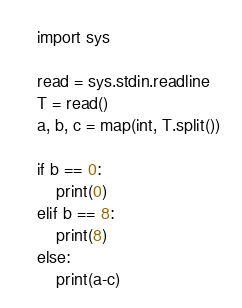<code> <loc_0><loc_0><loc_500><loc_500><_Python_>import sys

read = sys.stdin.readline
T = read()
a, b, c = map(int, T.split())

if b == 0:
    print(0)
elif b == 8:
    print(8)
else:
    print(a-c)</code> 